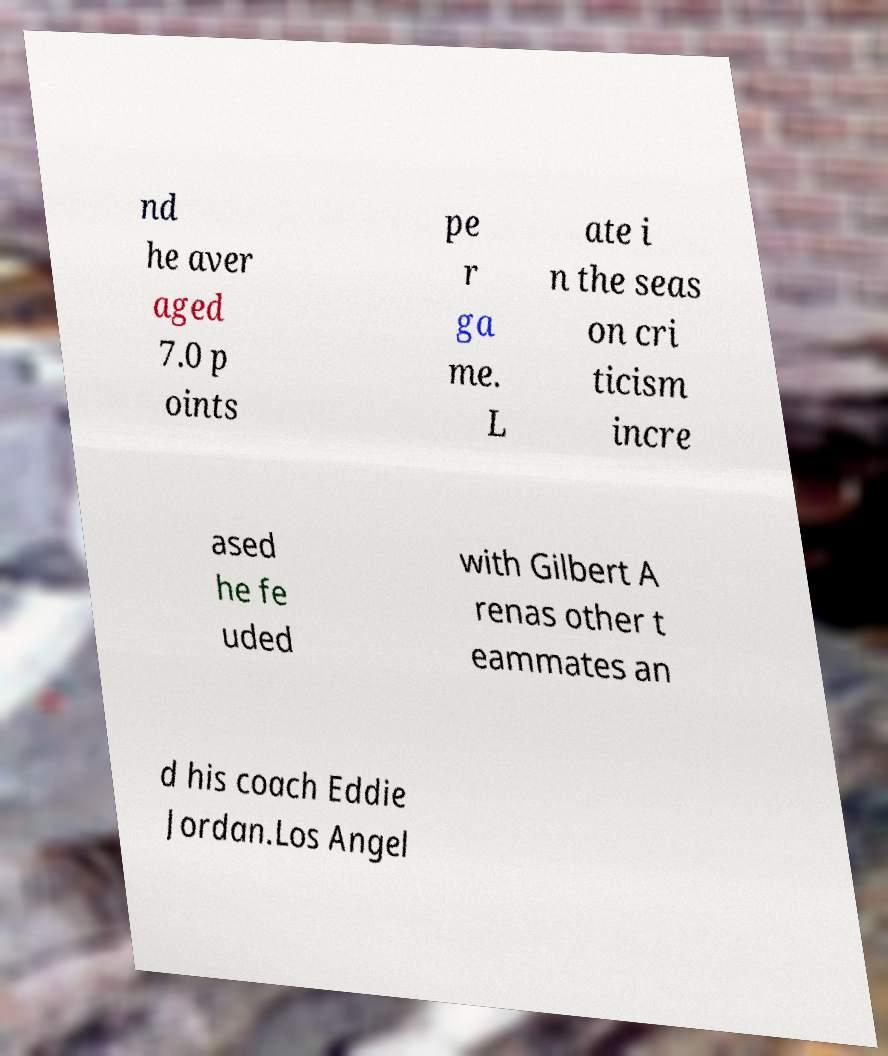I need the written content from this picture converted into text. Can you do that? nd he aver aged 7.0 p oints pe r ga me. L ate i n the seas on cri ticism incre ased he fe uded with Gilbert A renas other t eammates an d his coach Eddie Jordan.Los Angel 